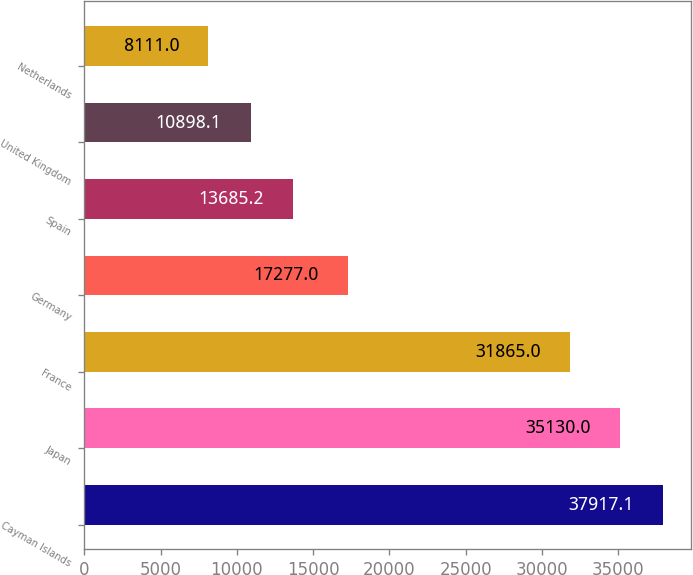<chart> <loc_0><loc_0><loc_500><loc_500><bar_chart><fcel>Cayman Islands<fcel>Japan<fcel>France<fcel>Germany<fcel>Spain<fcel>United Kingdom<fcel>Netherlands<nl><fcel>37917.1<fcel>35130<fcel>31865<fcel>17277<fcel>13685.2<fcel>10898.1<fcel>8111<nl></chart> 